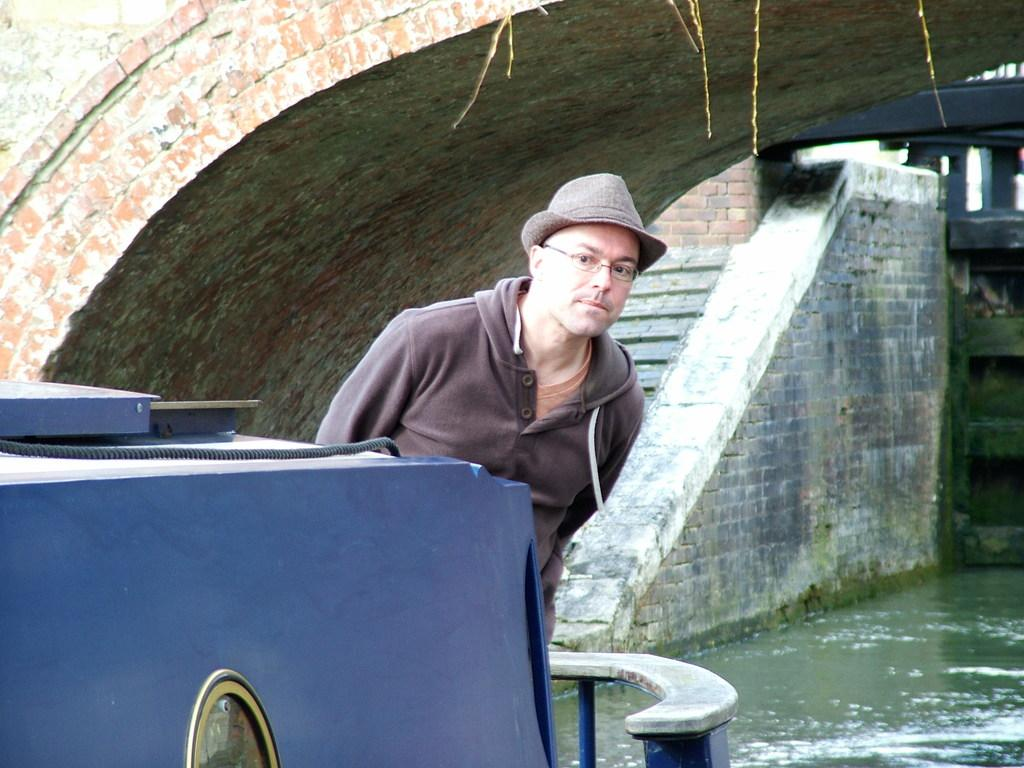What is the person in the image doing? The person is standing on a boat. Where is the boat located? The boat is on a lake. What architectural feature can be seen in the image? There are stairs in the image. What material is used to construct the wall in the image? The wall is made of stone bricks. What type of silk is draped over the wall in the image? There is no silk present in the image; the wall is made of stone bricks. 